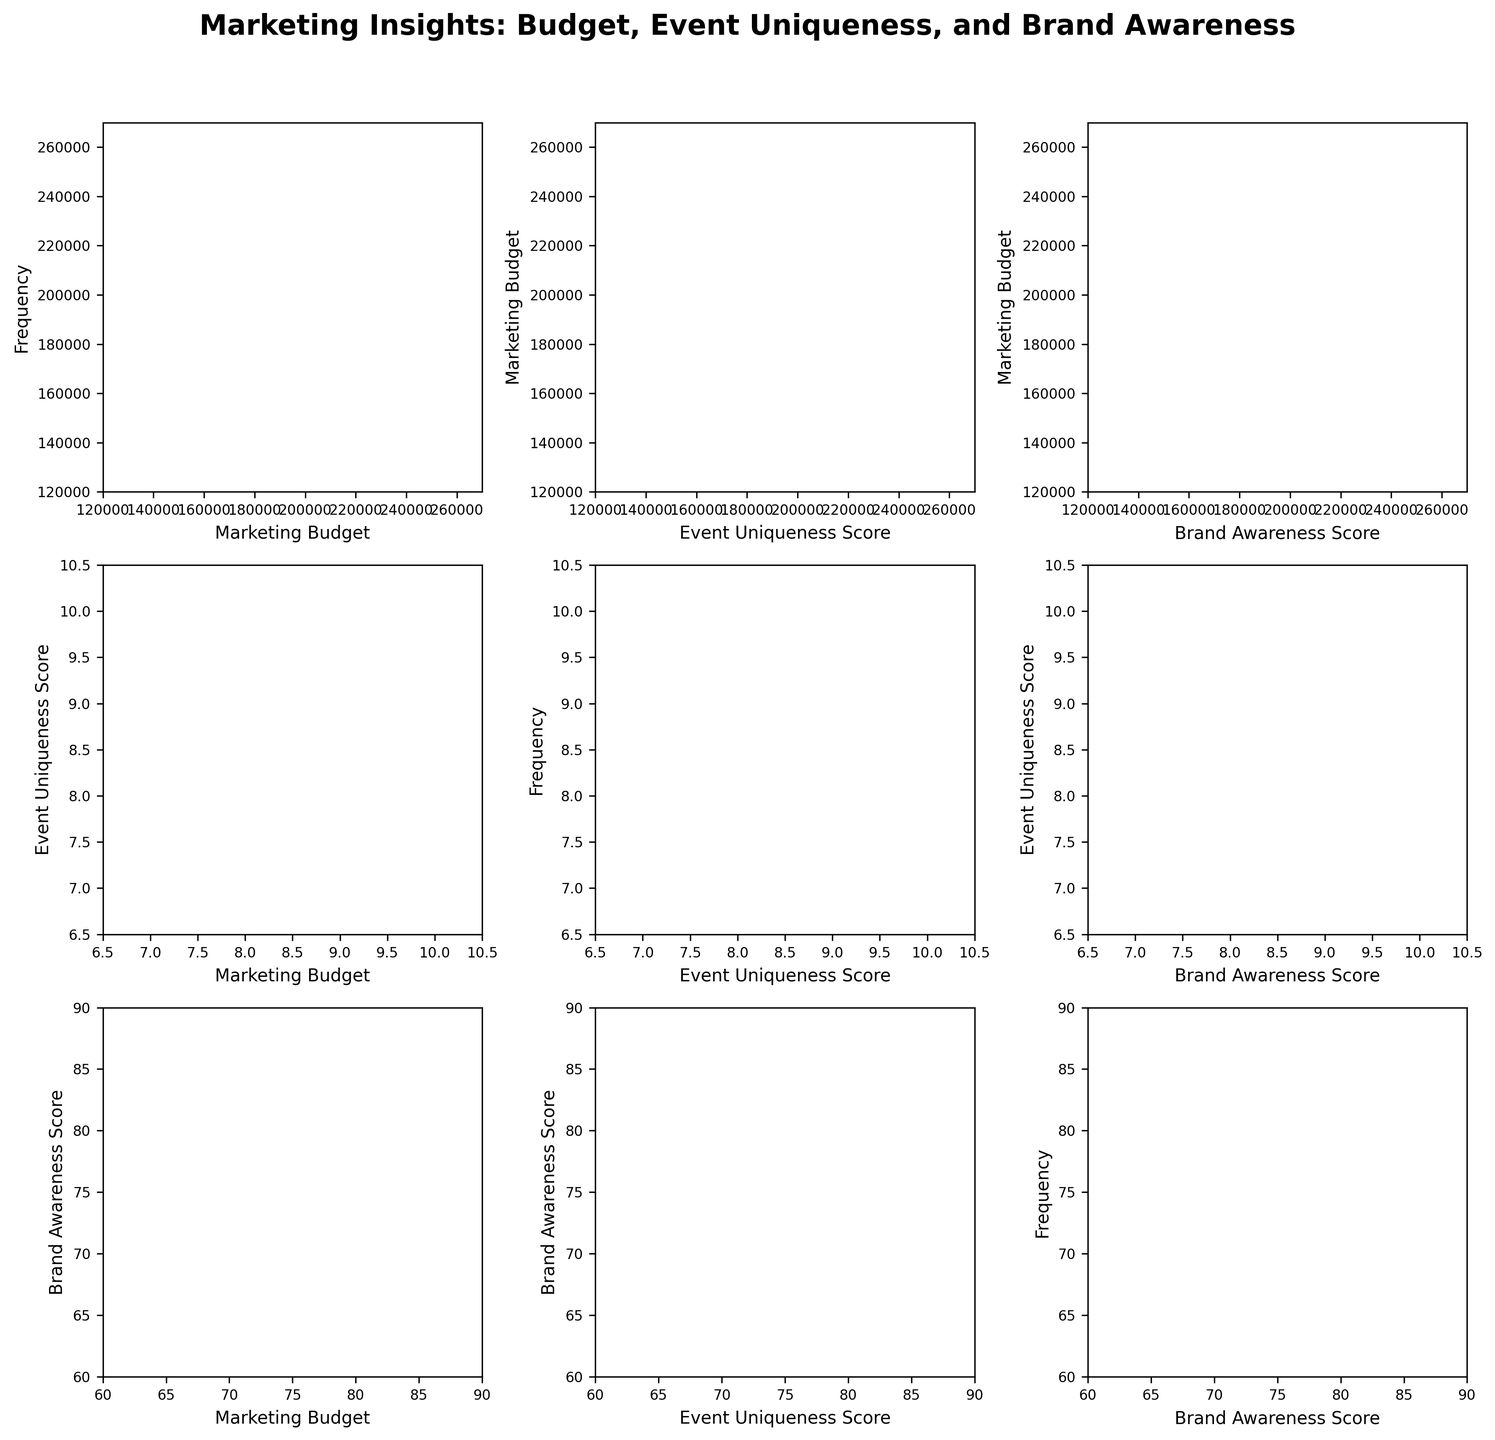What is the title of the figure? The title of the figure is displayed at the top and reads "Marketing Insights: Budget, Event Uniqueness, and Brand Awareness".
Answer: Marketing Insights: Budget, Event Uniqueness, and Brand Awareness How many data points are there in each scatter plot? Each scatter plot has 20 data points, represented by the individual dots. You can count the number of dots in any scatter plot to verify.
Answer: 20 What color represents higher Brand Awareness Score in the scatter plots? The color that represents higher Brand Awareness Score is on the purple end of the viridis colormap, which ranges from yellow (lower score) to purple (higher score).
Answer: purple What is the x-axis label of the scatter plot in the first row and second column? The x-axis label of the scatter plot in the first row and second column is "Event Uniqueness Score".
Answer: Event Uniqueness Score Which variable shows the widest range in its histogram? By looking at the histograms in the diagonal of the grid, we can see that "Marketing Budget" shows the widest range, from about 130,000 to 260,000.
Answer: Marketing Budget How does the Brand Awareness Score generally relate to the Event Uniqueness Score in the scatter plots? Generally, there appears to be a positive correlation between the Brand Awareness Score and the Event Uniqueness Score; higher uniqueness scores are often accompanied by higher brand awareness scores.
Answer: Positive correlation Which two variables have the strongest visual correlation in the scatter plot matrix? The strongest visual correlation appears between "Event Uniqueness Score" and "Brand Awareness Score", as their scatter plot shows a consistent upward trend.
Answer: Event Uniqueness Score and Brand Awareness Score Between "Marketing Budget" and "Event Uniqueness Score", which one has a higher overall range? "Marketing Budget" ranges roughly from 130,000 to 260,000, whereas "Event Uniqueness Score" ranges from about 7 to 10. The range for the budget is much larger.
Answer: Marketing Budget Is there any variable that shows a clear trend when plotted against itself in the histograms on the diagonals? No, since histograms are used to show the frequency distribution of single variables, not trends. Therefore, no clear trend is observable in the histograms on the diagonals.
Answer: No 